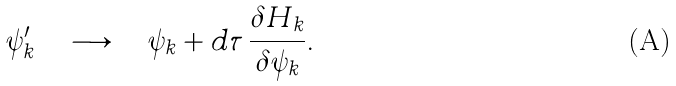<formula> <loc_0><loc_0><loc_500><loc_500>\psi _ { k } ^ { \prime } \quad \longrightarrow \quad \psi _ { k } + d \tau \, \frac { \delta H _ { k } } { \delta \psi _ { k } } .</formula> 